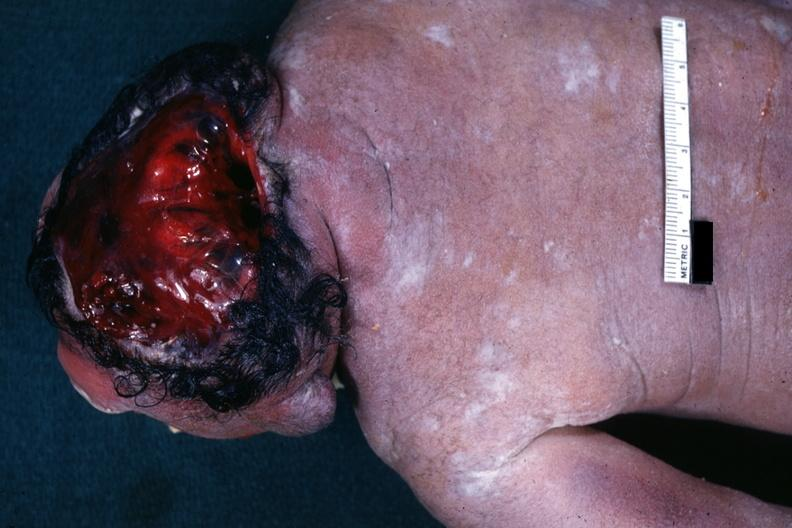does retroperitoneum show view from back typical example?
Answer the question using a single word or phrase. No 